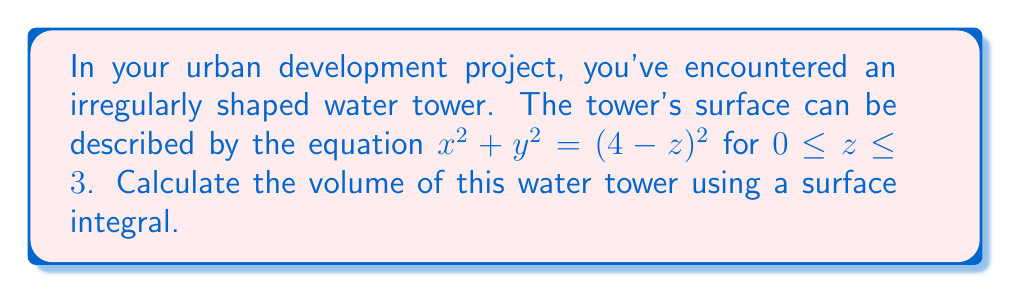Can you solve this math problem? Let's approach this step-by-step:

1) The surface of the water tower is described by $x^2 + y^2 = (4-z)^2$ for $0 \leq z \leq 3$. This is a cone-like shape with its base at $z=1$ and its tip at $z=4$.

2) To find the volume using a surface integral, we'll use the divergence theorem:

   $$\iiint_V \nabla \cdot \mathbf{F} \, dV = \iint_S \mathbf{F} \cdot \mathbf{n} \, dS$$

   where $\mathbf{F}$ is any vector field whose divergence is 1.

3) Let's choose $\mathbf{F} = \frac{1}{3}(x, y, z)$. The divergence of this field is:

   $$\nabla \cdot \mathbf{F} = \frac{\partial}{\partial x}(\frac{1}{3}x) + \frac{\partial}{\partial y}(\frac{1}{3}y) + \frac{\partial}{\partial z}(\frac{1}{3}z) = 1$$

4) Now, we need to find the outward unit normal vector $\mathbf{n}$. For the surface $x^2 + y^2 = (4-z)^2$, it's:

   $$\mathbf{n} = \frac{(x, y, 2(4-z))}{\sqrt{x^2 + y^2 + 4(4-z)^2}}$$

5) The surface integral becomes:

   $$\text{Volume} = \frac{1}{3}\iint_S (x^2 + y^2 + z(4-z)) \, \frac{dS}{\sqrt{x^2 + y^2 + 4(4-z)^2}}$$

6) We can parameterize the surface using cylindrical coordinates:
   $x = r\cos\theta$, $y = r\sin\theta$, $r = 4-z$

7) The surface element $dS$ becomes:

   $$dS = \sqrt{1 + (\frac{dr}{dz})^2} \, r \, d\theta \, dz = \sqrt{2} \, r \, d\theta \, dz$$

8) Substituting these into our integral:

   $$\text{Volume} = \frac{1}{3}\int_0^3 \int_0^{2\pi} ((4-z)^2 + z(4-z)) \, d\theta \, dz$$

9) Simplifying and integrating:

   $$\text{Volume} = \frac{2\pi}{3}\int_0^3 (16 - 8z + z^2 + 4z - z^2) \, dz = \frac{2\pi}{3}\int_0^3 (16 - 4z) \, dz$$

   $$= \frac{2\pi}{3}[16z - 2z^2]_0^3 = \frac{2\pi}{3}(48 - 18) = 20\pi$$

Therefore, the volume of the water tower is $20\pi$ cubic units.
Answer: $20\pi$ cubic units 